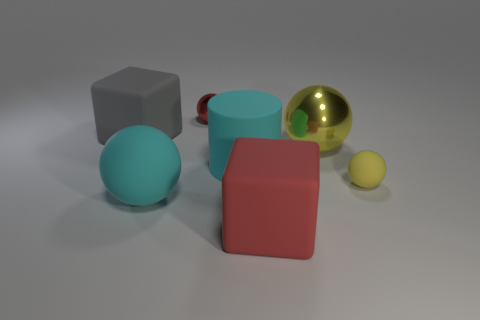Subtract 1 spheres. How many spheres are left? 3 Subtract all blue blocks. Subtract all purple cylinders. How many blocks are left? 2 Add 2 small brown things. How many objects exist? 9 Subtract all balls. How many objects are left? 3 Subtract all cylinders. Subtract all red matte blocks. How many objects are left? 5 Add 7 big shiny objects. How many big shiny objects are left? 8 Add 7 big cubes. How many big cubes exist? 9 Subtract 1 yellow spheres. How many objects are left? 6 